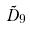<formula> <loc_0><loc_0><loc_500><loc_500>\tilde { D } _ { 9 }</formula> 